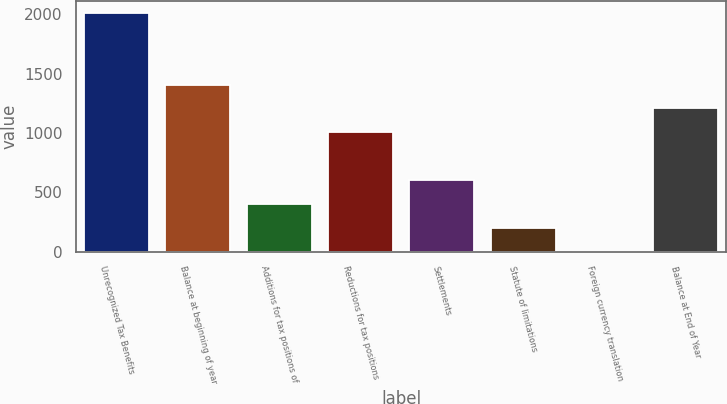<chart> <loc_0><loc_0><loc_500><loc_500><bar_chart><fcel>Unrecognized Tax Benefits<fcel>Balance at beginning of year<fcel>Additions for tax positions of<fcel>Reductions for tax positions<fcel>Settlements<fcel>Statute of limitations<fcel>Foreign currency translation<fcel>Balance at End of Year<nl><fcel>2011<fcel>1407.88<fcel>402.68<fcel>1005.8<fcel>603.72<fcel>201.64<fcel>0.6<fcel>1206.84<nl></chart> 